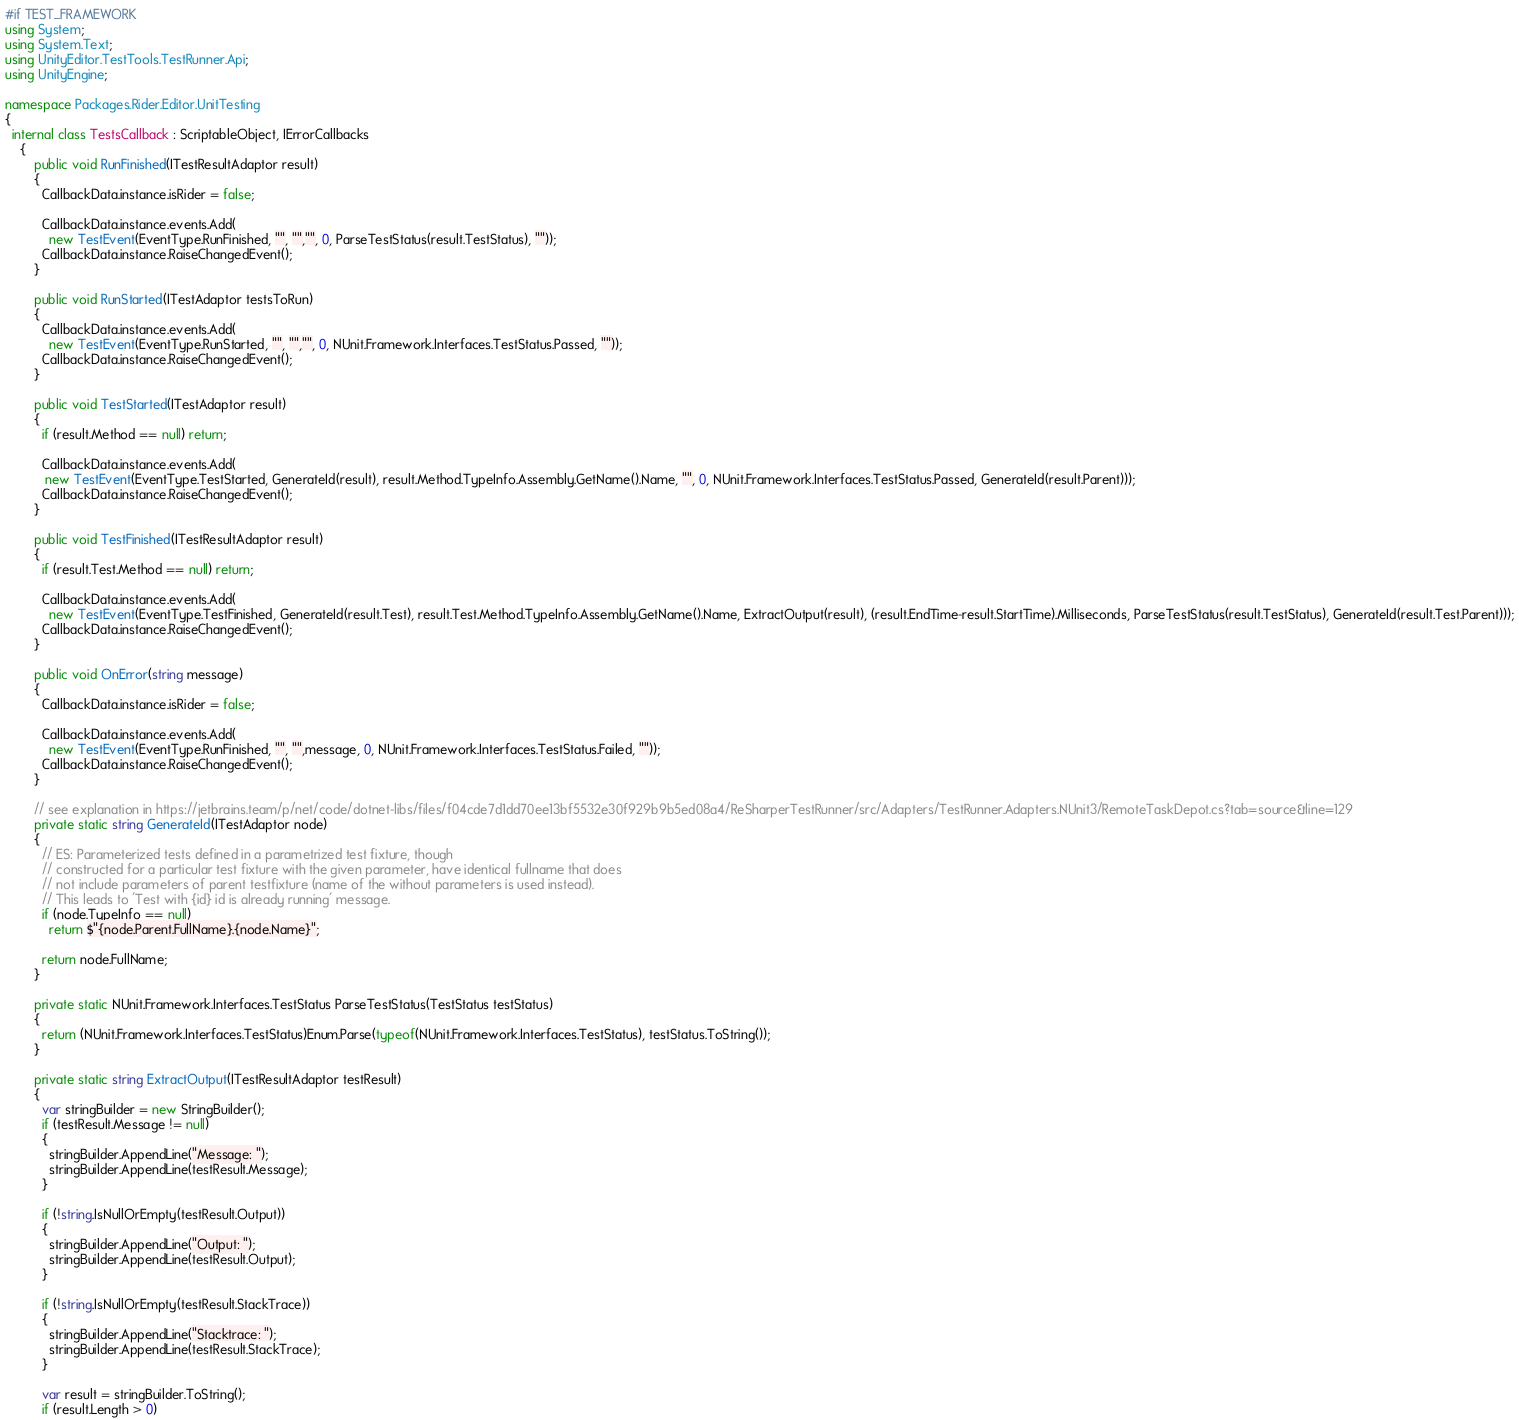<code> <loc_0><loc_0><loc_500><loc_500><_C#_>#if TEST_FRAMEWORK
using System;
using System.Text;
using UnityEditor.TestTools.TestRunner.Api;
using UnityEngine;

namespace Packages.Rider.Editor.UnitTesting
{
  internal class TestsCallback : ScriptableObject, IErrorCallbacks
    {
        public void RunFinished(ITestResultAdaptor result)
        {
          CallbackData.instance.isRider = false;
          
          CallbackData.instance.events.Add(
            new TestEvent(EventType.RunFinished, "", "","", 0, ParseTestStatus(result.TestStatus), ""));
          CallbackData.instance.RaiseChangedEvent();
        }
        
        public void RunStarted(ITestAdaptor testsToRun)
        {
          CallbackData.instance.events.Add(
            new TestEvent(EventType.RunStarted, "", "","", 0, NUnit.Framework.Interfaces.TestStatus.Passed, ""));
          CallbackData.instance.RaiseChangedEvent();
        }

        public void TestStarted(ITestAdaptor result)
        {
          if (result.Method == null) return;
          
          CallbackData.instance.events.Add(
           new TestEvent(EventType.TestStarted, GenerateId(result), result.Method.TypeInfo.Assembly.GetName().Name, "", 0, NUnit.Framework.Interfaces.TestStatus.Passed, GenerateId(result.Parent)));
          CallbackData.instance.RaiseChangedEvent();
        }

        public void TestFinished(ITestResultAdaptor result)
        {
          if (result.Test.Method == null) return;
          
          CallbackData.instance.events.Add(
            new TestEvent(EventType.TestFinished, GenerateId(result.Test), result.Test.Method.TypeInfo.Assembly.GetName().Name, ExtractOutput(result), (result.EndTime-result.StartTime).Milliseconds, ParseTestStatus(result.TestStatus), GenerateId(result.Test.Parent)));
          CallbackData.instance.RaiseChangedEvent();
        }

        public void OnError(string message)
        {
          CallbackData.instance.isRider = false;
          
          CallbackData.instance.events.Add(
            new TestEvent(EventType.RunFinished, "", "",message, 0, NUnit.Framework.Interfaces.TestStatus.Failed, ""));
          CallbackData.instance.RaiseChangedEvent();
        }

        // see explanation in https://jetbrains.team/p/net/code/dotnet-libs/files/f04cde7d1dd70ee13bf5532e30f929b9b5ed08a4/ReSharperTestRunner/src/Adapters/TestRunner.Adapters.NUnit3/RemoteTaskDepot.cs?tab=source&line=129
        private static string GenerateId(ITestAdaptor node)
        {
          // ES: Parameterized tests defined in a parametrized test fixture, though 
          // constructed for a particular test fixture with the given parameter, have identical fullname that does
          // not include parameters of parent testfixture (name of the without parameters is used instead).
          // This leads to 'Test with {id} id is already running' message.
          if (node.TypeInfo == null) 
            return $"{node.Parent.FullName}.{node.Name}";

          return node.FullName;
        }

        private static NUnit.Framework.Interfaces.TestStatus ParseTestStatus(TestStatus testStatus)
        {
          return (NUnit.Framework.Interfaces.TestStatus)Enum.Parse(typeof(NUnit.Framework.Interfaces.TestStatus), testStatus.ToString());
        }
        
        private static string ExtractOutput(ITestResultAdaptor testResult)
        {
          var stringBuilder = new StringBuilder();
          if (testResult.Message != null)
          {
            stringBuilder.AppendLine("Message: ");
            stringBuilder.AppendLine(testResult.Message);
          }

          if (!string.IsNullOrEmpty(testResult.Output))
          {
            stringBuilder.AppendLine("Output: ");
            stringBuilder.AppendLine(testResult.Output);
          }

          if (!string.IsNullOrEmpty(testResult.StackTrace))
          {
            stringBuilder.AppendLine("Stacktrace: ");
            stringBuilder.AppendLine(testResult.StackTrace);
          }
      
          var result = stringBuilder.ToString();
          if (result.Length > 0)</code> 